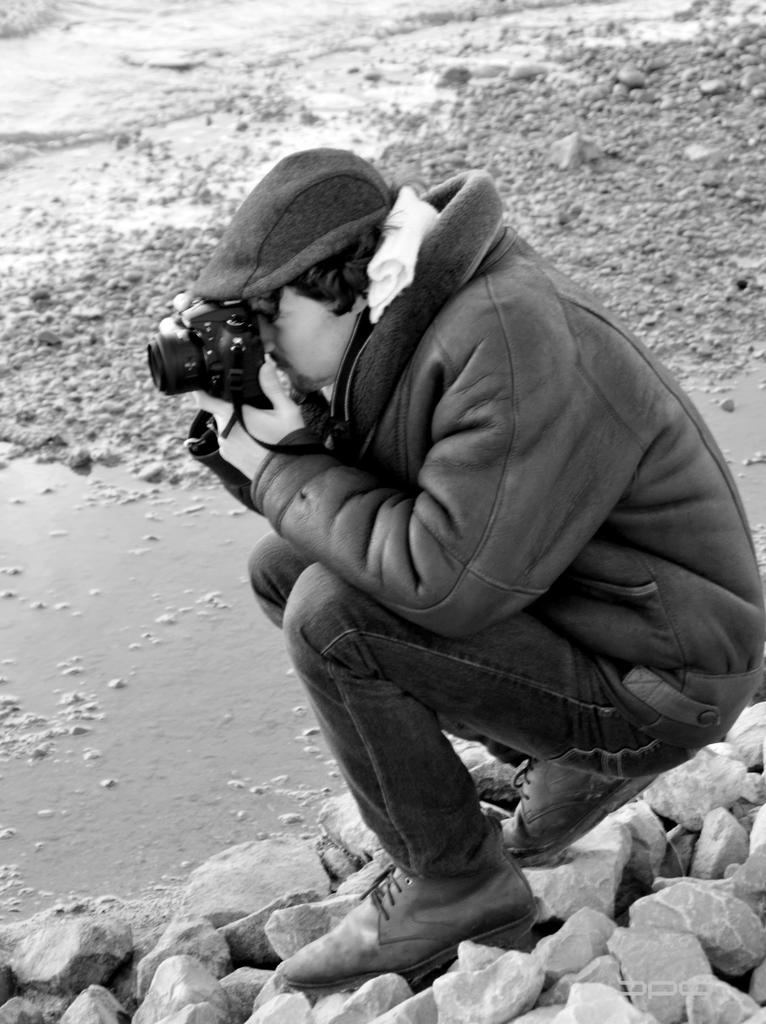What is the main subject of the image? There is a person in the image. What is the person holding in the image? The person is holding a camera. Where is the person sitting in the image? The person is sitting on stones. What is visible in front of the person? There is little water in front of the person. What type of poisonous grape is the person holding in the image? There is no grape present in the image, and the person is holding a camera, not a grape. How many snakes can be seen slithering around the person in the image? There are no snakes visible in the image; the person is sitting on stones with little water in front of them. 